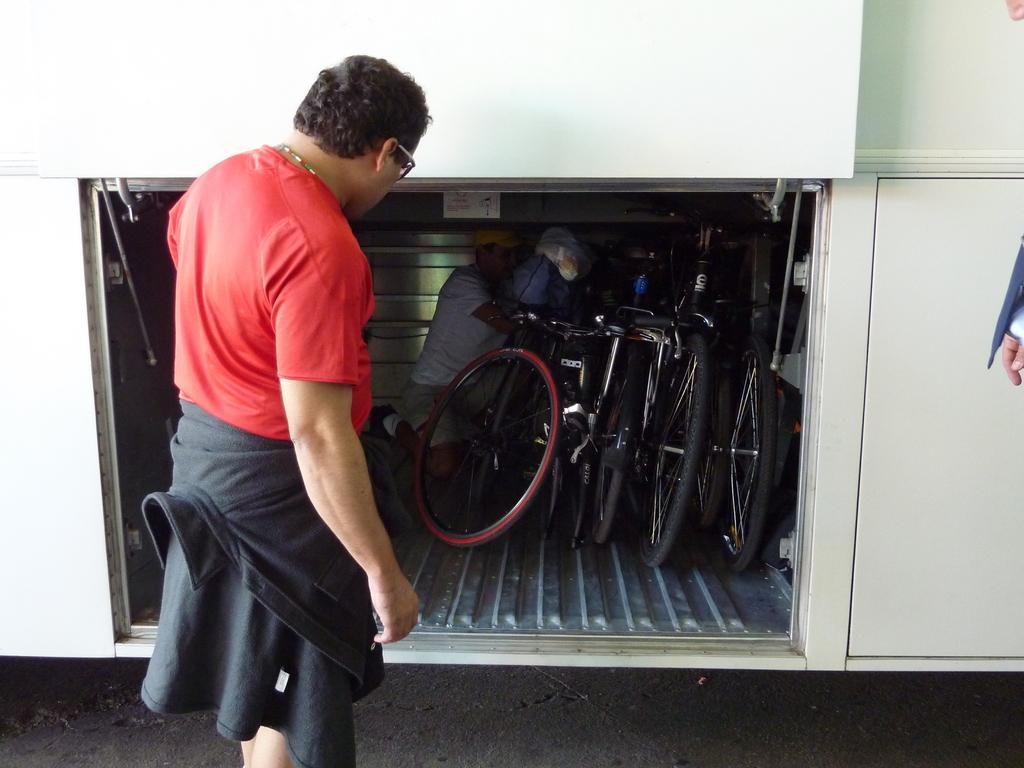How many people are in the image? There are two persons in the image. What objects are associated with the persons in the image? There are bicycles in the image. Can you describe an unusual situation involving one of the persons in the image? There is a person inside a vehicle trunk in the image. What is the behavior of the minute in the image? There is no mention of a minute in the image, as it refers to a unit of time and not a subject in the image. 